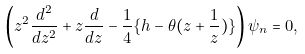<formula> <loc_0><loc_0><loc_500><loc_500>\left ( z ^ { 2 } { \frac { d ^ { 2 } } { d z ^ { 2 } } } + z { \frac { d } { d z } } - { \frac { 1 } { 4 } } \{ h - \theta ( z + { \frac { 1 } { z } } ) \} \right ) \psi _ { n } = 0 ,</formula> 